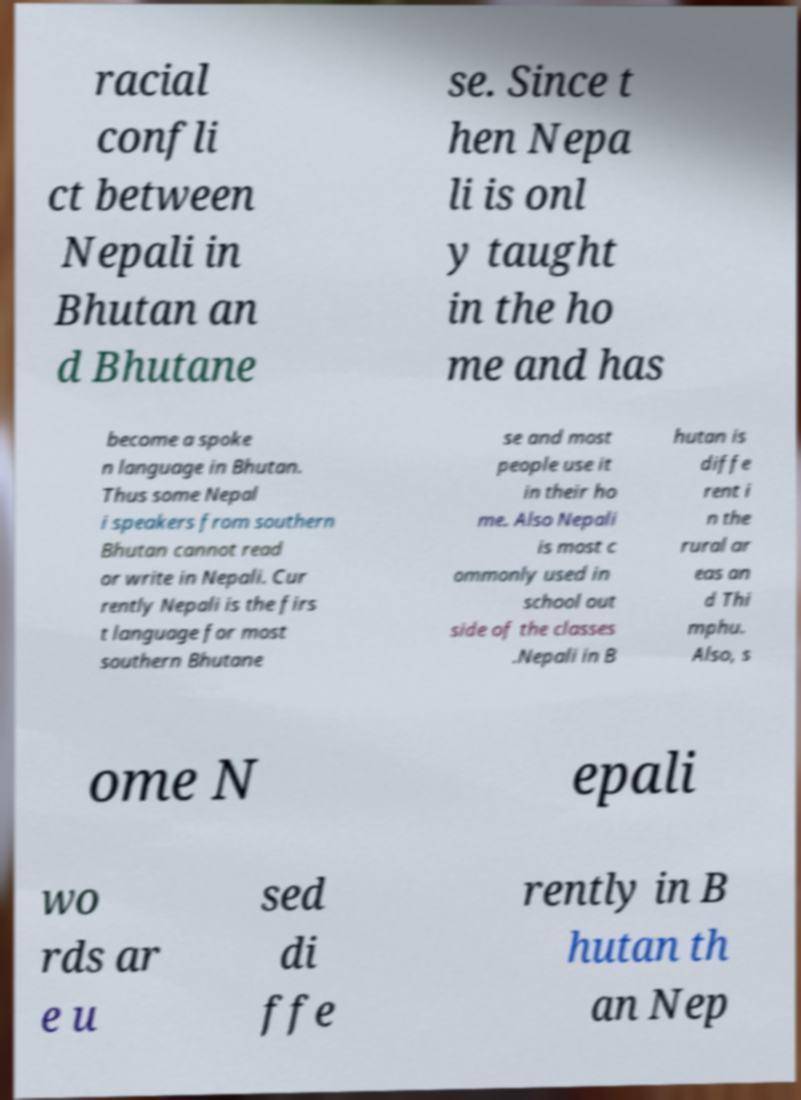What messages or text are displayed in this image? I need them in a readable, typed format. racial confli ct between Nepali in Bhutan an d Bhutane se. Since t hen Nepa li is onl y taught in the ho me and has become a spoke n language in Bhutan. Thus some Nepal i speakers from southern Bhutan cannot read or write in Nepali. Cur rently Nepali is the firs t language for most southern Bhutane se and most people use it in their ho me. Also Nepali is most c ommonly used in school out side of the classes .Nepali in B hutan is diffe rent i n the rural ar eas an d Thi mphu. Also, s ome N epali wo rds ar e u sed di ffe rently in B hutan th an Nep 